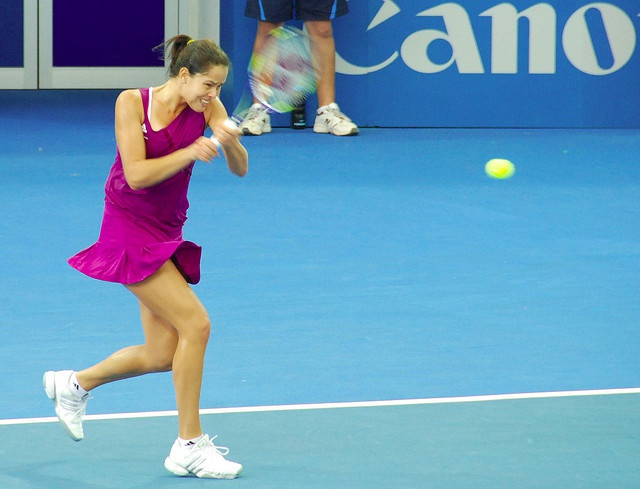Describe the objects in this image and their specific colors. I can see people in navy, tan, white, and purple tones, people in navy, tan, black, gray, and darkgray tones, tennis racket in navy, darkgray, teal, tan, and gray tones, and sports ball in navy, khaki, lightgreen, and yellow tones in this image. 